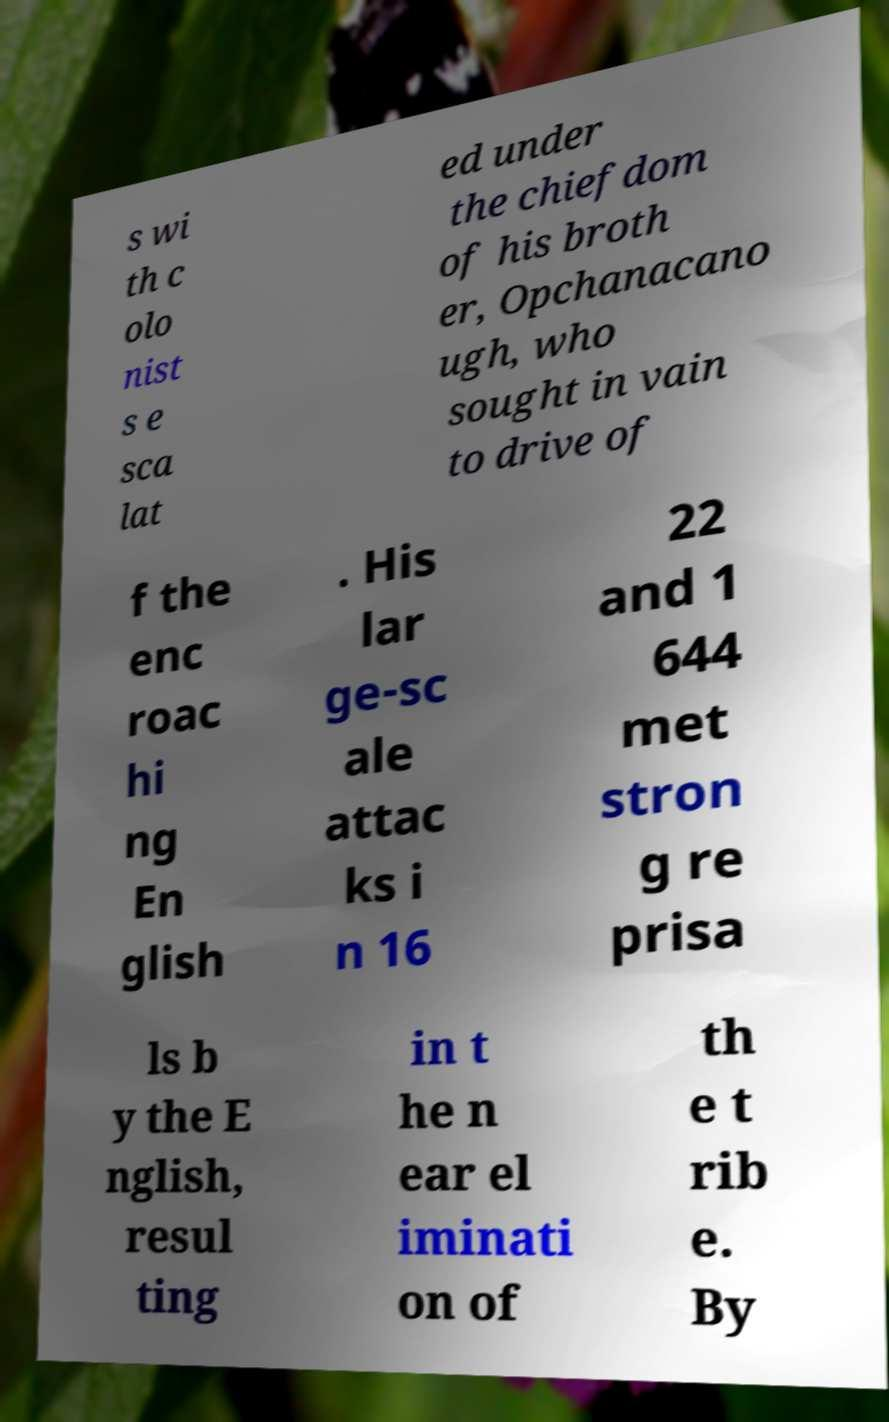Could you extract and type out the text from this image? s wi th c olo nist s e sca lat ed under the chiefdom of his broth er, Opchanacano ugh, who sought in vain to drive of f the enc roac hi ng En glish . His lar ge-sc ale attac ks i n 16 22 and 1 644 met stron g re prisa ls b y the E nglish, resul ting in t he n ear el iminati on of th e t rib e. By 